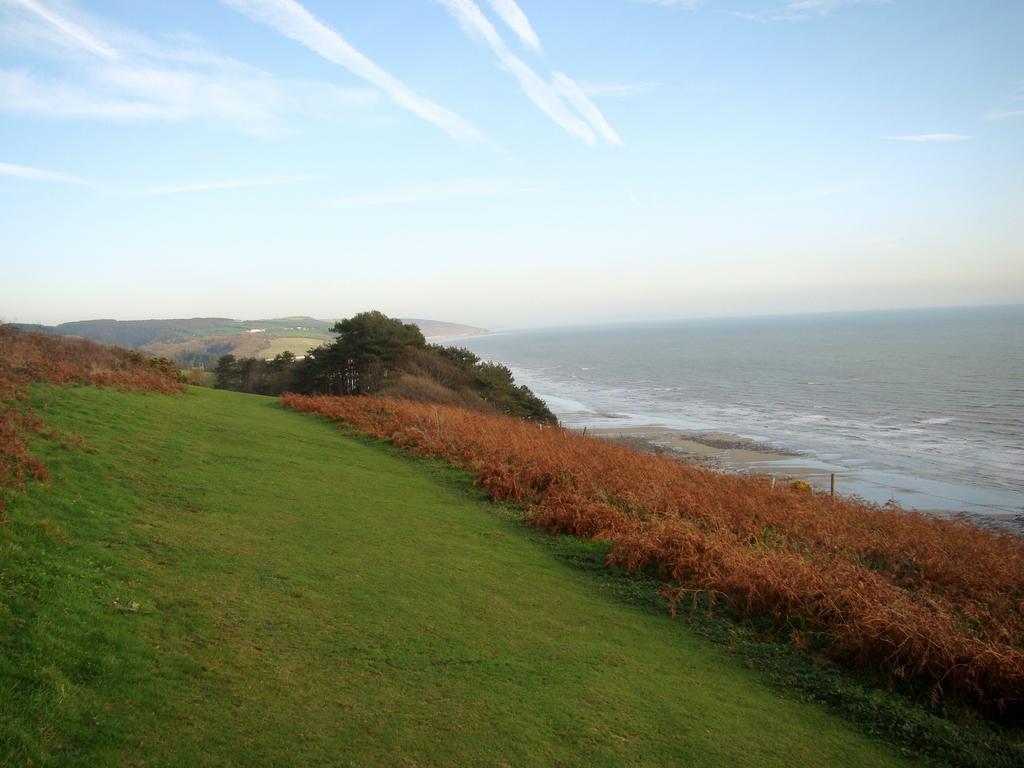Can you describe this image briefly? In this image I can see there is a water. And there are plants and trees. And there is a grass on the ground. And at the top there is a sky. 